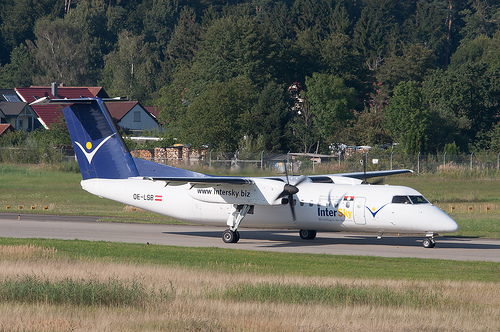Please provide a short description for this region: [0.6, 0.62, 0.63, 0.64]. The region at coordinates [0.6, 0.62, 0.63, 0.64] likely corresponds to the left rear landing gear of the airplane, providing structural support during landing and ground operations. 